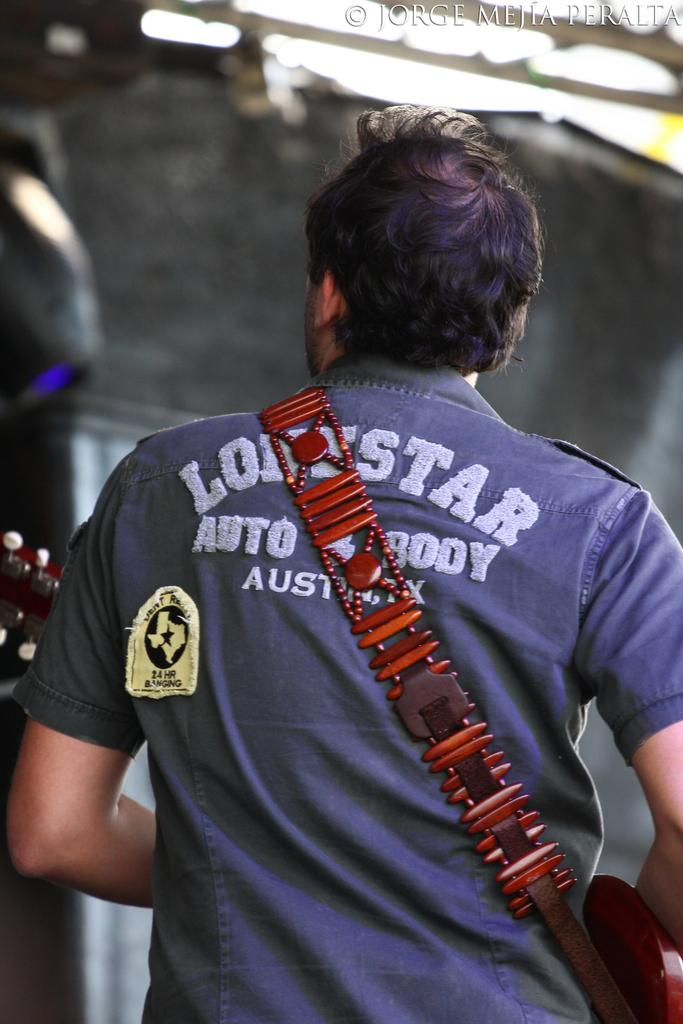Provide a one-sentence caption for the provided image. A man is walking with a lonestar shirt. 